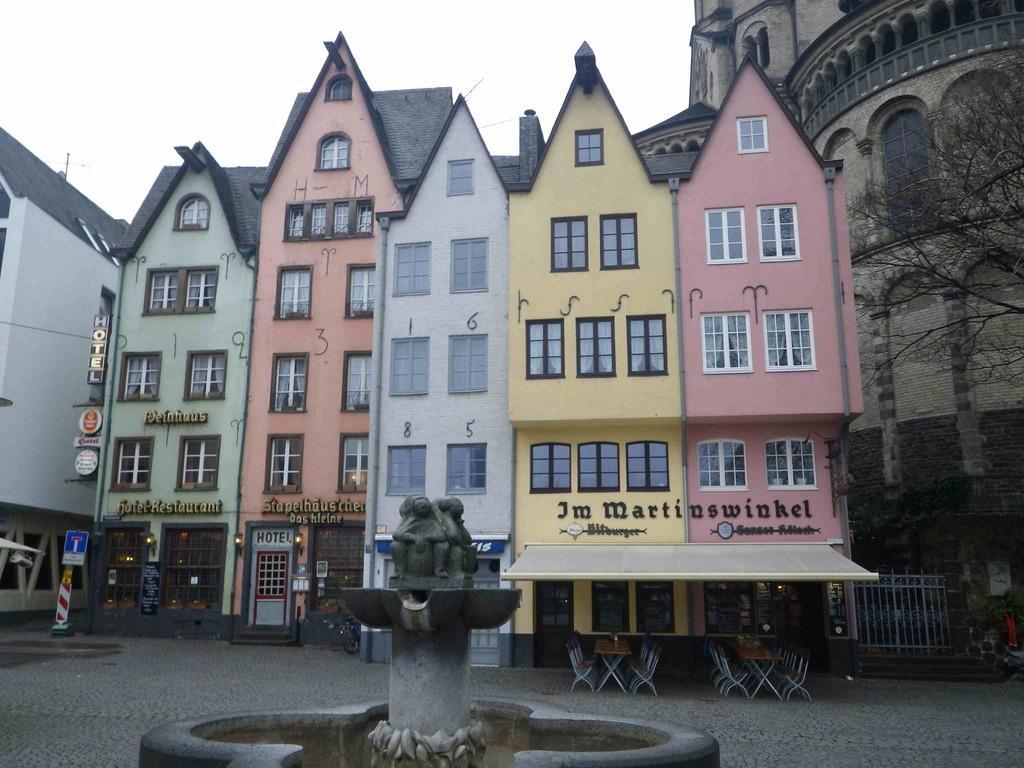How would you summarize this image in a sentence or two? In this picture we can see few sign boards, a statue in front of the buildings, and also we can see few hoardings, chairs and trees. 